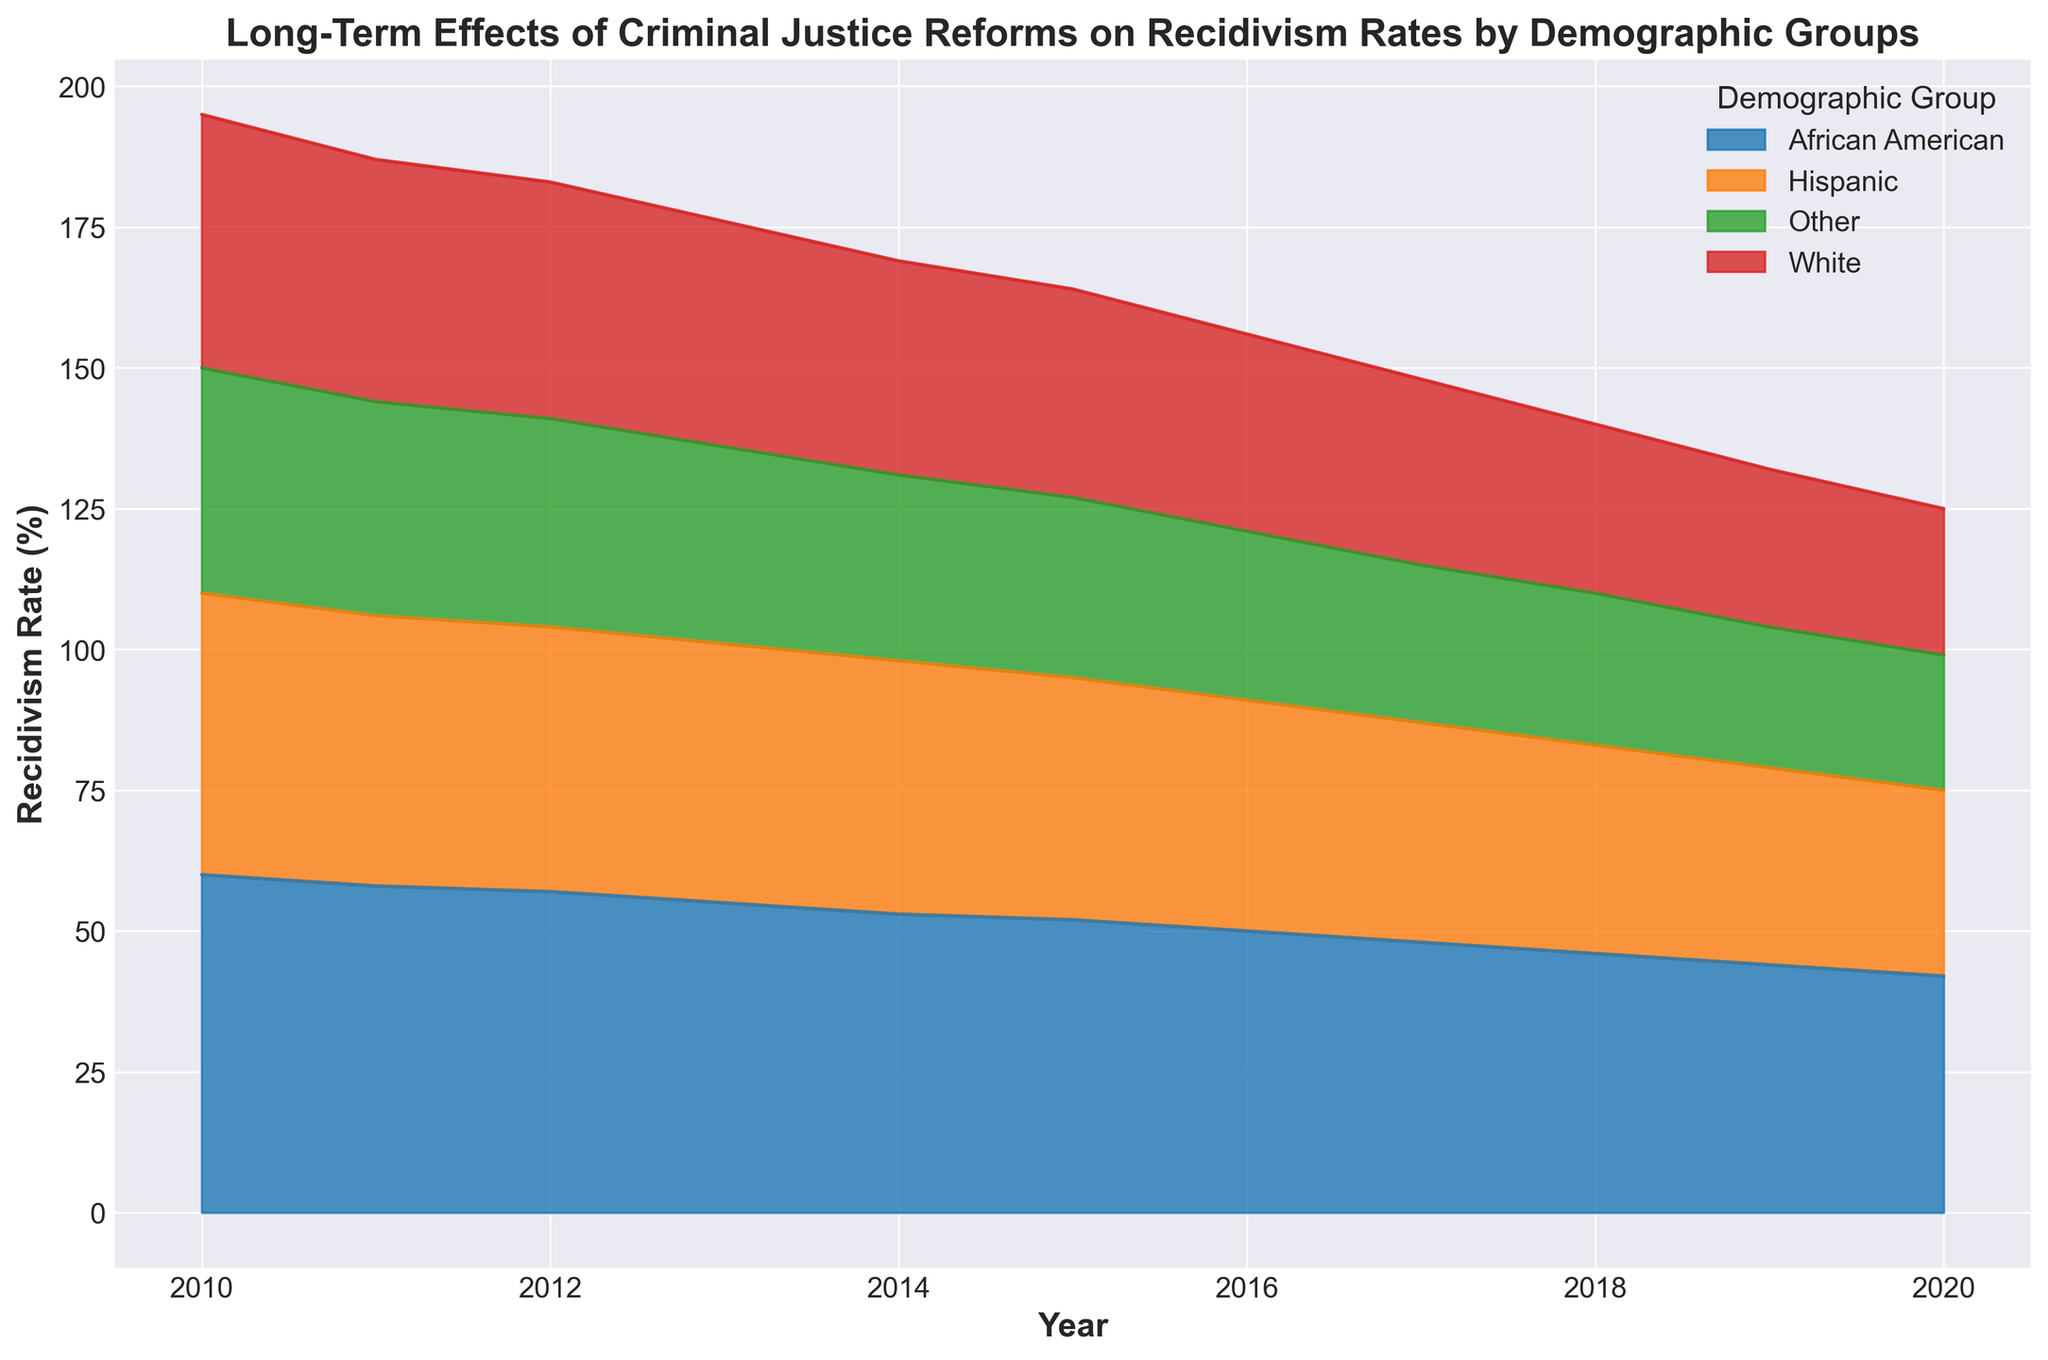Which demographic group had the highest recidivism rate in 2010? The area chart shows different colored sections for each demographic group. By looking at the height of the sections in 2010, the African American group has the highest section, indicating the highest recidivism rate.
Answer: African American How did the recidivism rate for Hispanic groups change from 2010 to 2020? By comparing the heights of the sections for the Hispanic group in 2010 and 2020, it is evident that the height decreased, indicating a reduction in the recidivism rate.
Answer: Decreased What is the general trend in the recidivism rate for all demographic groups from 2010 to 2020? Observing the overall shape and height of the different sections from 2010 to 2020, it is clear that all demographic groups show a downward trend in the recidivism rate.
Answer: Downward trend Which year shows the sharpest decline in recidivism rate for the African American group? By visually inspecting the recidivism rate for the African American group year by year, the decline appears sharpest between 2014 and 2015.
Answer: 2015 Compare the recidivism rates of the White and African American groups in 2015. Which group had a higher recidivism rate? Looking at the sections in 2015 for both White and African American groups, the African American section is higher, indicating a higher recidivism rate.
Answer: African American By how many percentage points did the recidivism rate for the White group decrease from 2010 to 2020? The recidivism rate for the White group in 2010 was 45%, and in 2020 it was 26%. The difference is 45% - 26% = 19 percentage points.
Answer: 19 percentage points Which demographic group had the smallest improvement in recidivism rate from 2010 to 2020? By observing the sections for each demographic group in 2010 and 2020, the 'Other' group sees the smallest change in height, indicating the smallest improvement.
Answer: Other What is the combined recidivism rate of the Hispanic and Other groups in 2018? In 2018, the recidivism rates for Hispanic and Other groups are 37% and 27%, respectively. Adding these together gives 37% + 27% = 64%.
Answer: 64% Which demographic group had a consistent decrease in recidivism rate every year from 2010 to 2020? By examining the chart and checking the height of each section year by year, the White group shows a consistent decrease each year.
Answer: White What is the approximate average recidivism rate for the African American group over the period 2010-2020? Summing the recidivism rates for the African American group from 2010 to 2020: (60 + 58 + 57 + 55 + 53 + 52 + 50 + 48 + 46 + 44 + 42) = 565. There are 11 years, so the average is 565 / 11 ≈ 51.36%.
Answer: 51.36% 